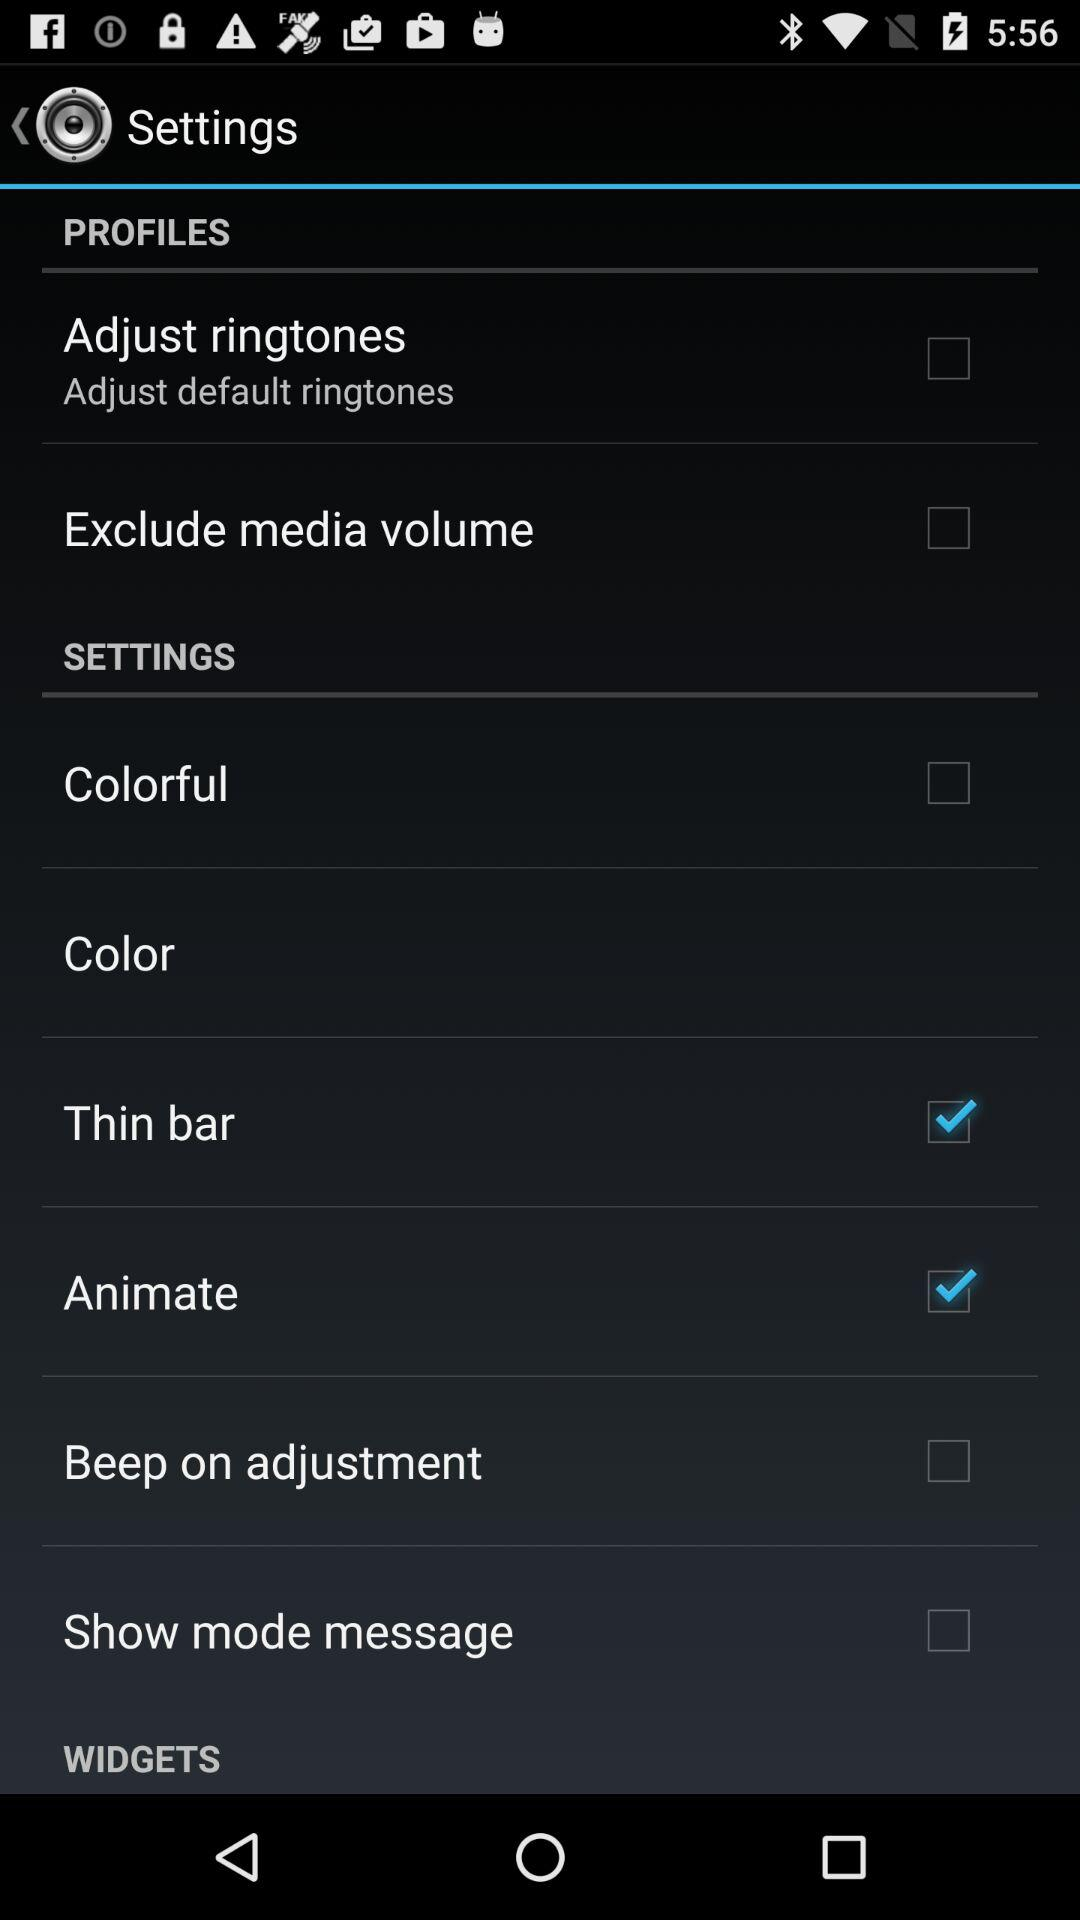What is the status of "Animate"? The status is "on". 